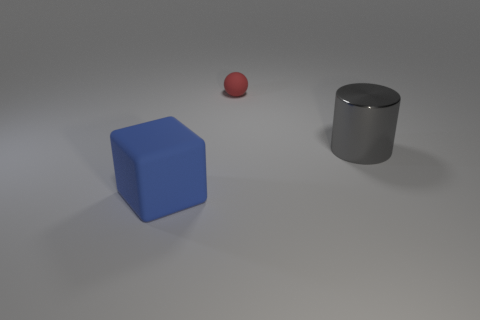Can you estimate the sizes of these objects relative to one another? The blue cube appears to have the largest dimensions of the three objects, followed by the gray cylinder. The red sphere is the smallest. Without a frame of reference for real-world size, exact measurements are not possible, but their size relationship to each other is apparent. 